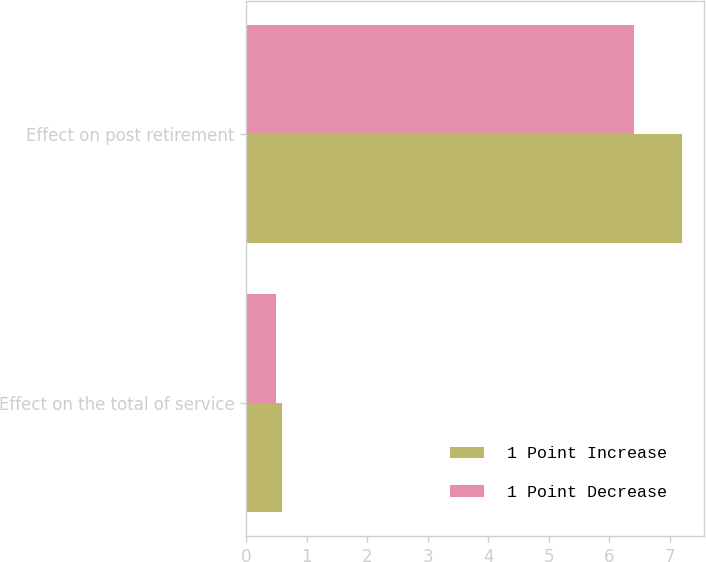Convert chart. <chart><loc_0><loc_0><loc_500><loc_500><stacked_bar_chart><ecel><fcel>Effect on the total of service<fcel>Effect on post retirement<nl><fcel>1 Point Increase<fcel>0.6<fcel>7.2<nl><fcel>1 Point Decrease<fcel>0.5<fcel>6.4<nl></chart> 